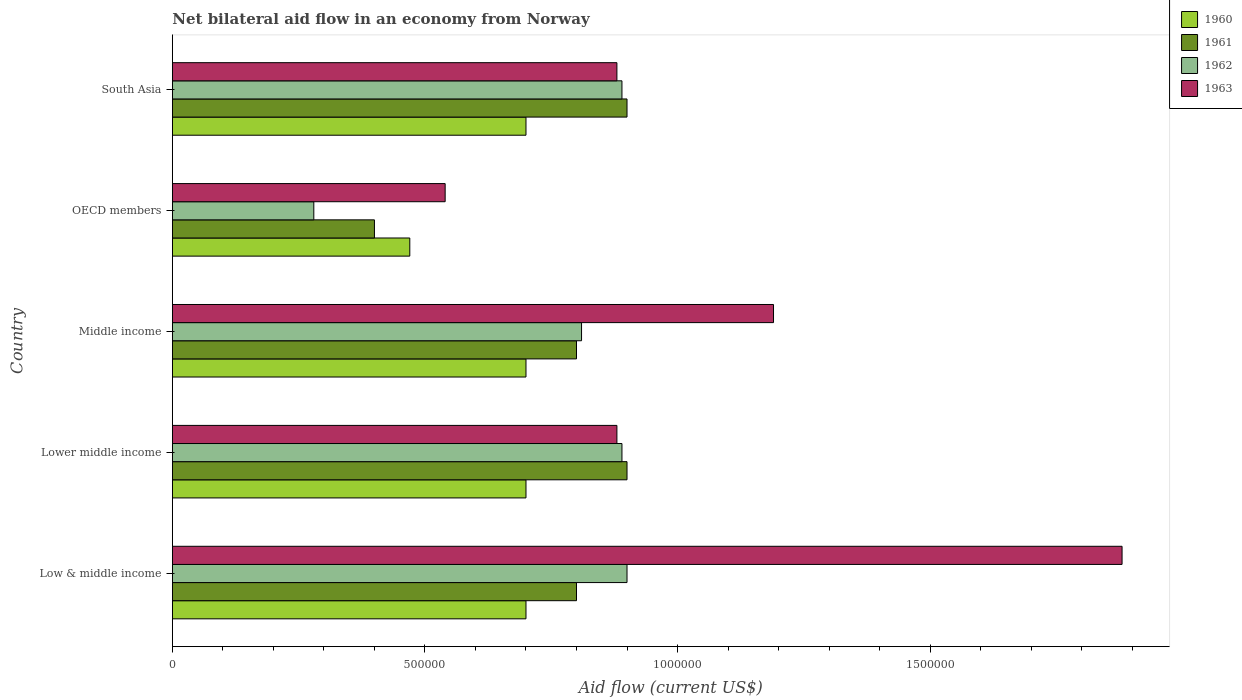Are the number of bars per tick equal to the number of legend labels?
Your response must be concise. Yes. How many bars are there on the 2nd tick from the top?
Keep it short and to the point. 4. What is the net bilateral aid flow in 1960 in Low & middle income?
Provide a short and direct response. 7.00e+05. Across all countries, what is the minimum net bilateral aid flow in 1960?
Offer a terse response. 4.70e+05. In which country was the net bilateral aid flow in 1962 minimum?
Keep it short and to the point. OECD members. What is the total net bilateral aid flow in 1962 in the graph?
Give a very brief answer. 3.77e+06. What is the difference between the net bilateral aid flow in 1961 in Lower middle income and that in Middle income?
Offer a terse response. 1.00e+05. What is the difference between the net bilateral aid flow in 1963 in OECD members and the net bilateral aid flow in 1960 in Middle income?
Keep it short and to the point. -1.60e+05. What is the average net bilateral aid flow in 1963 per country?
Offer a very short reply. 1.07e+06. What is the difference between the net bilateral aid flow in 1963 and net bilateral aid flow in 1961 in Low & middle income?
Give a very brief answer. 1.08e+06. What is the ratio of the net bilateral aid flow in 1962 in Middle income to that in OECD members?
Offer a very short reply. 2.89. What is the difference between the highest and the second highest net bilateral aid flow in 1962?
Provide a short and direct response. 10000. What is the difference between the highest and the lowest net bilateral aid flow in 1960?
Ensure brevity in your answer.  2.30e+05. What does the 1st bar from the top in Lower middle income represents?
Keep it short and to the point. 1963. Are all the bars in the graph horizontal?
Your answer should be compact. Yes. What is the difference between two consecutive major ticks on the X-axis?
Give a very brief answer. 5.00e+05. What is the title of the graph?
Keep it short and to the point. Net bilateral aid flow in an economy from Norway. Does "2006" appear as one of the legend labels in the graph?
Your answer should be compact. No. What is the label or title of the Y-axis?
Provide a short and direct response. Country. What is the Aid flow (current US$) in 1961 in Low & middle income?
Your answer should be very brief. 8.00e+05. What is the Aid flow (current US$) in 1962 in Low & middle income?
Your answer should be very brief. 9.00e+05. What is the Aid flow (current US$) of 1963 in Low & middle income?
Your response must be concise. 1.88e+06. What is the Aid flow (current US$) in 1961 in Lower middle income?
Give a very brief answer. 9.00e+05. What is the Aid flow (current US$) of 1962 in Lower middle income?
Make the answer very short. 8.90e+05. What is the Aid flow (current US$) of 1963 in Lower middle income?
Make the answer very short. 8.80e+05. What is the Aid flow (current US$) of 1960 in Middle income?
Make the answer very short. 7.00e+05. What is the Aid flow (current US$) of 1962 in Middle income?
Keep it short and to the point. 8.10e+05. What is the Aid flow (current US$) in 1963 in Middle income?
Provide a short and direct response. 1.19e+06. What is the Aid flow (current US$) of 1960 in OECD members?
Make the answer very short. 4.70e+05. What is the Aid flow (current US$) of 1961 in OECD members?
Give a very brief answer. 4.00e+05. What is the Aid flow (current US$) in 1962 in OECD members?
Your response must be concise. 2.80e+05. What is the Aid flow (current US$) of 1963 in OECD members?
Provide a succinct answer. 5.40e+05. What is the Aid flow (current US$) in 1960 in South Asia?
Your answer should be very brief. 7.00e+05. What is the Aid flow (current US$) of 1962 in South Asia?
Offer a terse response. 8.90e+05. What is the Aid flow (current US$) in 1963 in South Asia?
Offer a terse response. 8.80e+05. Across all countries, what is the maximum Aid flow (current US$) of 1962?
Provide a succinct answer. 9.00e+05. Across all countries, what is the maximum Aid flow (current US$) of 1963?
Keep it short and to the point. 1.88e+06. Across all countries, what is the minimum Aid flow (current US$) in 1960?
Your response must be concise. 4.70e+05. Across all countries, what is the minimum Aid flow (current US$) of 1962?
Your answer should be very brief. 2.80e+05. Across all countries, what is the minimum Aid flow (current US$) in 1963?
Make the answer very short. 5.40e+05. What is the total Aid flow (current US$) of 1960 in the graph?
Make the answer very short. 3.27e+06. What is the total Aid flow (current US$) of 1961 in the graph?
Your response must be concise. 3.80e+06. What is the total Aid flow (current US$) of 1962 in the graph?
Provide a succinct answer. 3.77e+06. What is the total Aid flow (current US$) in 1963 in the graph?
Offer a terse response. 5.37e+06. What is the difference between the Aid flow (current US$) of 1960 in Low & middle income and that in Lower middle income?
Make the answer very short. 0. What is the difference between the Aid flow (current US$) of 1961 in Low & middle income and that in Lower middle income?
Your answer should be very brief. -1.00e+05. What is the difference between the Aid flow (current US$) of 1962 in Low & middle income and that in Lower middle income?
Keep it short and to the point. 10000. What is the difference between the Aid flow (current US$) of 1960 in Low & middle income and that in Middle income?
Offer a terse response. 0. What is the difference between the Aid flow (current US$) in 1961 in Low & middle income and that in Middle income?
Keep it short and to the point. 0. What is the difference between the Aid flow (current US$) of 1962 in Low & middle income and that in Middle income?
Offer a very short reply. 9.00e+04. What is the difference between the Aid flow (current US$) of 1963 in Low & middle income and that in Middle income?
Your response must be concise. 6.90e+05. What is the difference between the Aid flow (current US$) of 1960 in Low & middle income and that in OECD members?
Your answer should be compact. 2.30e+05. What is the difference between the Aid flow (current US$) in 1961 in Low & middle income and that in OECD members?
Ensure brevity in your answer.  4.00e+05. What is the difference between the Aid flow (current US$) of 1962 in Low & middle income and that in OECD members?
Ensure brevity in your answer.  6.20e+05. What is the difference between the Aid flow (current US$) in 1963 in Low & middle income and that in OECD members?
Offer a terse response. 1.34e+06. What is the difference between the Aid flow (current US$) in 1960 in Low & middle income and that in South Asia?
Offer a very short reply. 0. What is the difference between the Aid flow (current US$) of 1961 in Low & middle income and that in South Asia?
Offer a terse response. -1.00e+05. What is the difference between the Aid flow (current US$) in 1960 in Lower middle income and that in Middle income?
Give a very brief answer. 0. What is the difference between the Aid flow (current US$) in 1962 in Lower middle income and that in Middle income?
Offer a terse response. 8.00e+04. What is the difference between the Aid flow (current US$) of 1963 in Lower middle income and that in Middle income?
Make the answer very short. -3.10e+05. What is the difference between the Aid flow (current US$) of 1961 in Lower middle income and that in OECD members?
Provide a succinct answer. 5.00e+05. What is the difference between the Aid flow (current US$) in 1963 in Lower middle income and that in OECD members?
Offer a terse response. 3.40e+05. What is the difference between the Aid flow (current US$) in 1961 in Lower middle income and that in South Asia?
Provide a succinct answer. 0. What is the difference between the Aid flow (current US$) of 1962 in Middle income and that in OECD members?
Give a very brief answer. 5.30e+05. What is the difference between the Aid flow (current US$) of 1963 in Middle income and that in OECD members?
Give a very brief answer. 6.50e+05. What is the difference between the Aid flow (current US$) in 1961 in Middle income and that in South Asia?
Your answer should be very brief. -1.00e+05. What is the difference between the Aid flow (current US$) of 1962 in Middle income and that in South Asia?
Offer a terse response. -8.00e+04. What is the difference between the Aid flow (current US$) of 1963 in Middle income and that in South Asia?
Keep it short and to the point. 3.10e+05. What is the difference between the Aid flow (current US$) of 1960 in OECD members and that in South Asia?
Your answer should be very brief. -2.30e+05. What is the difference between the Aid flow (current US$) of 1961 in OECD members and that in South Asia?
Provide a short and direct response. -5.00e+05. What is the difference between the Aid flow (current US$) of 1962 in OECD members and that in South Asia?
Ensure brevity in your answer.  -6.10e+05. What is the difference between the Aid flow (current US$) of 1963 in OECD members and that in South Asia?
Your answer should be compact. -3.40e+05. What is the difference between the Aid flow (current US$) in 1960 in Low & middle income and the Aid flow (current US$) in 1961 in Lower middle income?
Your answer should be very brief. -2.00e+05. What is the difference between the Aid flow (current US$) of 1960 in Low & middle income and the Aid flow (current US$) of 1963 in Lower middle income?
Your answer should be very brief. -1.80e+05. What is the difference between the Aid flow (current US$) in 1961 in Low & middle income and the Aid flow (current US$) in 1962 in Lower middle income?
Offer a very short reply. -9.00e+04. What is the difference between the Aid flow (current US$) of 1961 in Low & middle income and the Aid flow (current US$) of 1963 in Lower middle income?
Ensure brevity in your answer.  -8.00e+04. What is the difference between the Aid flow (current US$) in 1962 in Low & middle income and the Aid flow (current US$) in 1963 in Lower middle income?
Provide a succinct answer. 2.00e+04. What is the difference between the Aid flow (current US$) of 1960 in Low & middle income and the Aid flow (current US$) of 1961 in Middle income?
Provide a short and direct response. -1.00e+05. What is the difference between the Aid flow (current US$) in 1960 in Low & middle income and the Aid flow (current US$) in 1962 in Middle income?
Provide a succinct answer. -1.10e+05. What is the difference between the Aid flow (current US$) of 1960 in Low & middle income and the Aid flow (current US$) of 1963 in Middle income?
Your answer should be very brief. -4.90e+05. What is the difference between the Aid flow (current US$) in 1961 in Low & middle income and the Aid flow (current US$) in 1962 in Middle income?
Your answer should be compact. -10000. What is the difference between the Aid flow (current US$) in 1961 in Low & middle income and the Aid flow (current US$) in 1963 in Middle income?
Keep it short and to the point. -3.90e+05. What is the difference between the Aid flow (current US$) of 1960 in Low & middle income and the Aid flow (current US$) of 1962 in OECD members?
Your answer should be very brief. 4.20e+05. What is the difference between the Aid flow (current US$) in 1961 in Low & middle income and the Aid flow (current US$) in 1962 in OECD members?
Keep it short and to the point. 5.20e+05. What is the difference between the Aid flow (current US$) in 1961 in Low & middle income and the Aid flow (current US$) in 1963 in OECD members?
Keep it short and to the point. 2.60e+05. What is the difference between the Aid flow (current US$) of 1962 in Low & middle income and the Aid flow (current US$) of 1963 in OECD members?
Your response must be concise. 3.60e+05. What is the difference between the Aid flow (current US$) of 1960 in Low & middle income and the Aid flow (current US$) of 1961 in South Asia?
Your answer should be compact. -2.00e+05. What is the difference between the Aid flow (current US$) of 1962 in Low & middle income and the Aid flow (current US$) of 1963 in South Asia?
Make the answer very short. 2.00e+04. What is the difference between the Aid flow (current US$) of 1960 in Lower middle income and the Aid flow (current US$) of 1963 in Middle income?
Offer a terse response. -4.90e+05. What is the difference between the Aid flow (current US$) in 1961 in Lower middle income and the Aid flow (current US$) in 1962 in Middle income?
Keep it short and to the point. 9.00e+04. What is the difference between the Aid flow (current US$) of 1961 in Lower middle income and the Aid flow (current US$) of 1963 in Middle income?
Your answer should be compact. -2.90e+05. What is the difference between the Aid flow (current US$) of 1962 in Lower middle income and the Aid flow (current US$) of 1963 in Middle income?
Give a very brief answer. -3.00e+05. What is the difference between the Aid flow (current US$) of 1960 in Lower middle income and the Aid flow (current US$) of 1961 in OECD members?
Provide a short and direct response. 3.00e+05. What is the difference between the Aid flow (current US$) in 1960 in Lower middle income and the Aid flow (current US$) in 1962 in OECD members?
Give a very brief answer. 4.20e+05. What is the difference between the Aid flow (current US$) of 1960 in Lower middle income and the Aid flow (current US$) of 1963 in OECD members?
Offer a very short reply. 1.60e+05. What is the difference between the Aid flow (current US$) in 1961 in Lower middle income and the Aid flow (current US$) in 1962 in OECD members?
Give a very brief answer. 6.20e+05. What is the difference between the Aid flow (current US$) in 1962 in Lower middle income and the Aid flow (current US$) in 1963 in OECD members?
Make the answer very short. 3.50e+05. What is the difference between the Aid flow (current US$) in 1960 in Lower middle income and the Aid flow (current US$) in 1961 in South Asia?
Keep it short and to the point. -2.00e+05. What is the difference between the Aid flow (current US$) in 1960 in Lower middle income and the Aid flow (current US$) in 1962 in South Asia?
Provide a succinct answer. -1.90e+05. What is the difference between the Aid flow (current US$) in 1961 in Lower middle income and the Aid flow (current US$) in 1963 in South Asia?
Ensure brevity in your answer.  2.00e+04. What is the difference between the Aid flow (current US$) of 1962 in Lower middle income and the Aid flow (current US$) of 1963 in South Asia?
Your response must be concise. 10000. What is the difference between the Aid flow (current US$) of 1960 in Middle income and the Aid flow (current US$) of 1962 in OECD members?
Give a very brief answer. 4.20e+05. What is the difference between the Aid flow (current US$) of 1961 in Middle income and the Aid flow (current US$) of 1962 in OECD members?
Provide a short and direct response. 5.20e+05. What is the difference between the Aid flow (current US$) of 1960 in Middle income and the Aid flow (current US$) of 1961 in South Asia?
Your answer should be compact. -2.00e+05. What is the difference between the Aid flow (current US$) in 1961 in Middle income and the Aid flow (current US$) in 1962 in South Asia?
Offer a terse response. -9.00e+04. What is the difference between the Aid flow (current US$) in 1961 in Middle income and the Aid flow (current US$) in 1963 in South Asia?
Provide a succinct answer. -8.00e+04. What is the difference between the Aid flow (current US$) in 1960 in OECD members and the Aid flow (current US$) in 1961 in South Asia?
Give a very brief answer. -4.30e+05. What is the difference between the Aid flow (current US$) of 1960 in OECD members and the Aid flow (current US$) of 1962 in South Asia?
Provide a succinct answer. -4.20e+05. What is the difference between the Aid flow (current US$) of 1960 in OECD members and the Aid flow (current US$) of 1963 in South Asia?
Provide a short and direct response. -4.10e+05. What is the difference between the Aid flow (current US$) of 1961 in OECD members and the Aid flow (current US$) of 1962 in South Asia?
Your answer should be compact. -4.90e+05. What is the difference between the Aid flow (current US$) in 1961 in OECD members and the Aid flow (current US$) in 1963 in South Asia?
Keep it short and to the point. -4.80e+05. What is the difference between the Aid flow (current US$) in 1962 in OECD members and the Aid flow (current US$) in 1963 in South Asia?
Keep it short and to the point. -6.00e+05. What is the average Aid flow (current US$) of 1960 per country?
Ensure brevity in your answer.  6.54e+05. What is the average Aid flow (current US$) in 1961 per country?
Your answer should be very brief. 7.60e+05. What is the average Aid flow (current US$) in 1962 per country?
Offer a terse response. 7.54e+05. What is the average Aid flow (current US$) in 1963 per country?
Provide a succinct answer. 1.07e+06. What is the difference between the Aid flow (current US$) in 1960 and Aid flow (current US$) in 1961 in Low & middle income?
Your answer should be very brief. -1.00e+05. What is the difference between the Aid flow (current US$) of 1960 and Aid flow (current US$) of 1962 in Low & middle income?
Offer a very short reply. -2.00e+05. What is the difference between the Aid flow (current US$) of 1960 and Aid flow (current US$) of 1963 in Low & middle income?
Your response must be concise. -1.18e+06. What is the difference between the Aid flow (current US$) of 1961 and Aid flow (current US$) of 1962 in Low & middle income?
Make the answer very short. -1.00e+05. What is the difference between the Aid flow (current US$) of 1961 and Aid flow (current US$) of 1963 in Low & middle income?
Your response must be concise. -1.08e+06. What is the difference between the Aid flow (current US$) in 1962 and Aid flow (current US$) in 1963 in Low & middle income?
Provide a short and direct response. -9.80e+05. What is the difference between the Aid flow (current US$) in 1960 and Aid flow (current US$) in 1962 in Lower middle income?
Provide a succinct answer. -1.90e+05. What is the difference between the Aid flow (current US$) of 1961 and Aid flow (current US$) of 1963 in Lower middle income?
Give a very brief answer. 2.00e+04. What is the difference between the Aid flow (current US$) in 1960 and Aid flow (current US$) in 1962 in Middle income?
Your answer should be compact. -1.10e+05. What is the difference between the Aid flow (current US$) of 1960 and Aid flow (current US$) of 1963 in Middle income?
Offer a very short reply. -4.90e+05. What is the difference between the Aid flow (current US$) of 1961 and Aid flow (current US$) of 1963 in Middle income?
Offer a very short reply. -3.90e+05. What is the difference between the Aid flow (current US$) in 1962 and Aid flow (current US$) in 1963 in Middle income?
Provide a short and direct response. -3.80e+05. What is the difference between the Aid flow (current US$) of 1960 and Aid flow (current US$) of 1963 in OECD members?
Keep it short and to the point. -7.00e+04. What is the difference between the Aid flow (current US$) of 1961 and Aid flow (current US$) of 1963 in OECD members?
Ensure brevity in your answer.  -1.40e+05. What is the difference between the Aid flow (current US$) of 1962 and Aid flow (current US$) of 1963 in OECD members?
Your answer should be very brief. -2.60e+05. What is the difference between the Aid flow (current US$) of 1960 and Aid flow (current US$) of 1961 in South Asia?
Offer a very short reply. -2.00e+05. What is the difference between the Aid flow (current US$) in 1960 and Aid flow (current US$) in 1962 in South Asia?
Keep it short and to the point. -1.90e+05. What is the difference between the Aid flow (current US$) of 1960 and Aid flow (current US$) of 1963 in South Asia?
Offer a very short reply. -1.80e+05. What is the difference between the Aid flow (current US$) of 1961 and Aid flow (current US$) of 1962 in South Asia?
Provide a succinct answer. 10000. What is the difference between the Aid flow (current US$) of 1962 and Aid flow (current US$) of 1963 in South Asia?
Ensure brevity in your answer.  10000. What is the ratio of the Aid flow (current US$) of 1962 in Low & middle income to that in Lower middle income?
Provide a short and direct response. 1.01. What is the ratio of the Aid flow (current US$) in 1963 in Low & middle income to that in Lower middle income?
Make the answer very short. 2.14. What is the ratio of the Aid flow (current US$) of 1961 in Low & middle income to that in Middle income?
Give a very brief answer. 1. What is the ratio of the Aid flow (current US$) of 1962 in Low & middle income to that in Middle income?
Provide a short and direct response. 1.11. What is the ratio of the Aid flow (current US$) of 1963 in Low & middle income to that in Middle income?
Make the answer very short. 1.58. What is the ratio of the Aid flow (current US$) of 1960 in Low & middle income to that in OECD members?
Make the answer very short. 1.49. What is the ratio of the Aid flow (current US$) in 1961 in Low & middle income to that in OECD members?
Your answer should be compact. 2. What is the ratio of the Aid flow (current US$) of 1962 in Low & middle income to that in OECD members?
Ensure brevity in your answer.  3.21. What is the ratio of the Aid flow (current US$) in 1963 in Low & middle income to that in OECD members?
Your response must be concise. 3.48. What is the ratio of the Aid flow (current US$) of 1960 in Low & middle income to that in South Asia?
Provide a short and direct response. 1. What is the ratio of the Aid flow (current US$) in 1961 in Low & middle income to that in South Asia?
Provide a short and direct response. 0.89. What is the ratio of the Aid flow (current US$) of 1962 in Low & middle income to that in South Asia?
Offer a very short reply. 1.01. What is the ratio of the Aid flow (current US$) in 1963 in Low & middle income to that in South Asia?
Make the answer very short. 2.14. What is the ratio of the Aid flow (current US$) in 1960 in Lower middle income to that in Middle income?
Offer a terse response. 1. What is the ratio of the Aid flow (current US$) in 1962 in Lower middle income to that in Middle income?
Give a very brief answer. 1.1. What is the ratio of the Aid flow (current US$) in 1963 in Lower middle income to that in Middle income?
Offer a very short reply. 0.74. What is the ratio of the Aid flow (current US$) in 1960 in Lower middle income to that in OECD members?
Your answer should be very brief. 1.49. What is the ratio of the Aid flow (current US$) of 1961 in Lower middle income to that in OECD members?
Make the answer very short. 2.25. What is the ratio of the Aid flow (current US$) in 1962 in Lower middle income to that in OECD members?
Your answer should be compact. 3.18. What is the ratio of the Aid flow (current US$) of 1963 in Lower middle income to that in OECD members?
Ensure brevity in your answer.  1.63. What is the ratio of the Aid flow (current US$) of 1963 in Lower middle income to that in South Asia?
Your response must be concise. 1. What is the ratio of the Aid flow (current US$) of 1960 in Middle income to that in OECD members?
Keep it short and to the point. 1.49. What is the ratio of the Aid flow (current US$) in 1962 in Middle income to that in OECD members?
Offer a very short reply. 2.89. What is the ratio of the Aid flow (current US$) in 1963 in Middle income to that in OECD members?
Make the answer very short. 2.2. What is the ratio of the Aid flow (current US$) in 1960 in Middle income to that in South Asia?
Your answer should be compact. 1. What is the ratio of the Aid flow (current US$) of 1961 in Middle income to that in South Asia?
Offer a terse response. 0.89. What is the ratio of the Aid flow (current US$) in 1962 in Middle income to that in South Asia?
Provide a short and direct response. 0.91. What is the ratio of the Aid flow (current US$) in 1963 in Middle income to that in South Asia?
Provide a short and direct response. 1.35. What is the ratio of the Aid flow (current US$) in 1960 in OECD members to that in South Asia?
Make the answer very short. 0.67. What is the ratio of the Aid flow (current US$) of 1961 in OECD members to that in South Asia?
Your response must be concise. 0.44. What is the ratio of the Aid flow (current US$) in 1962 in OECD members to that in South Asia?
Your answer should be compact. 0.31. What is the ratio of the Aid flow (current US$) in 1963 in OECD members to that in South Asia?
Provide a succinct answer. 0.61. What is the difference between the highest and the second highest Aid flow (current US$) in 1961?
Your answer should be very brief. 0. What is the difference between the highest and the second highest Aid flow (current US$) of 1963?
Offer a terse response. 6.90e+05. What is the difference between the highest and the lowest Aid flow (current US$) in 1961?
Ensure brevity in your answer.  5.00e+05. What is the difference between the highest and the lowest Aid flow (current US$) in 1962?
Give a very brief answer. 6.20e+05. What is the difference between the highest and the lowest Aid flow (current US$) of 1963?
Make the answer very short. 1.34e+06. 